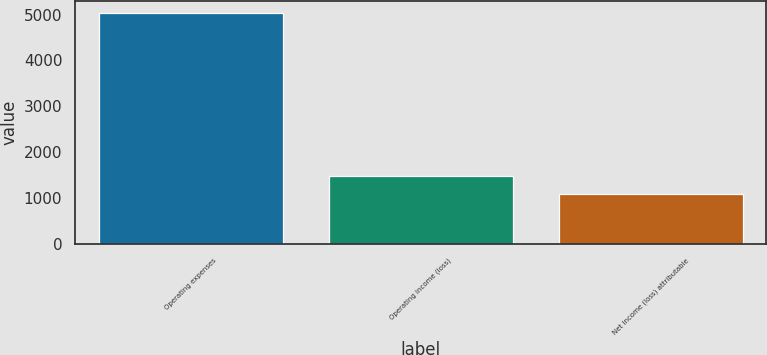Convert chart. <chart><loc_0><loc_0><loc_500><loc_500><bar_chart><fcel>Operating expenses<fcel>Operating income (loss)<fcel>Net income (loss) attributable<nl><fcel>5039<fcel>1472.3<fcel>1076<nl></chart> 